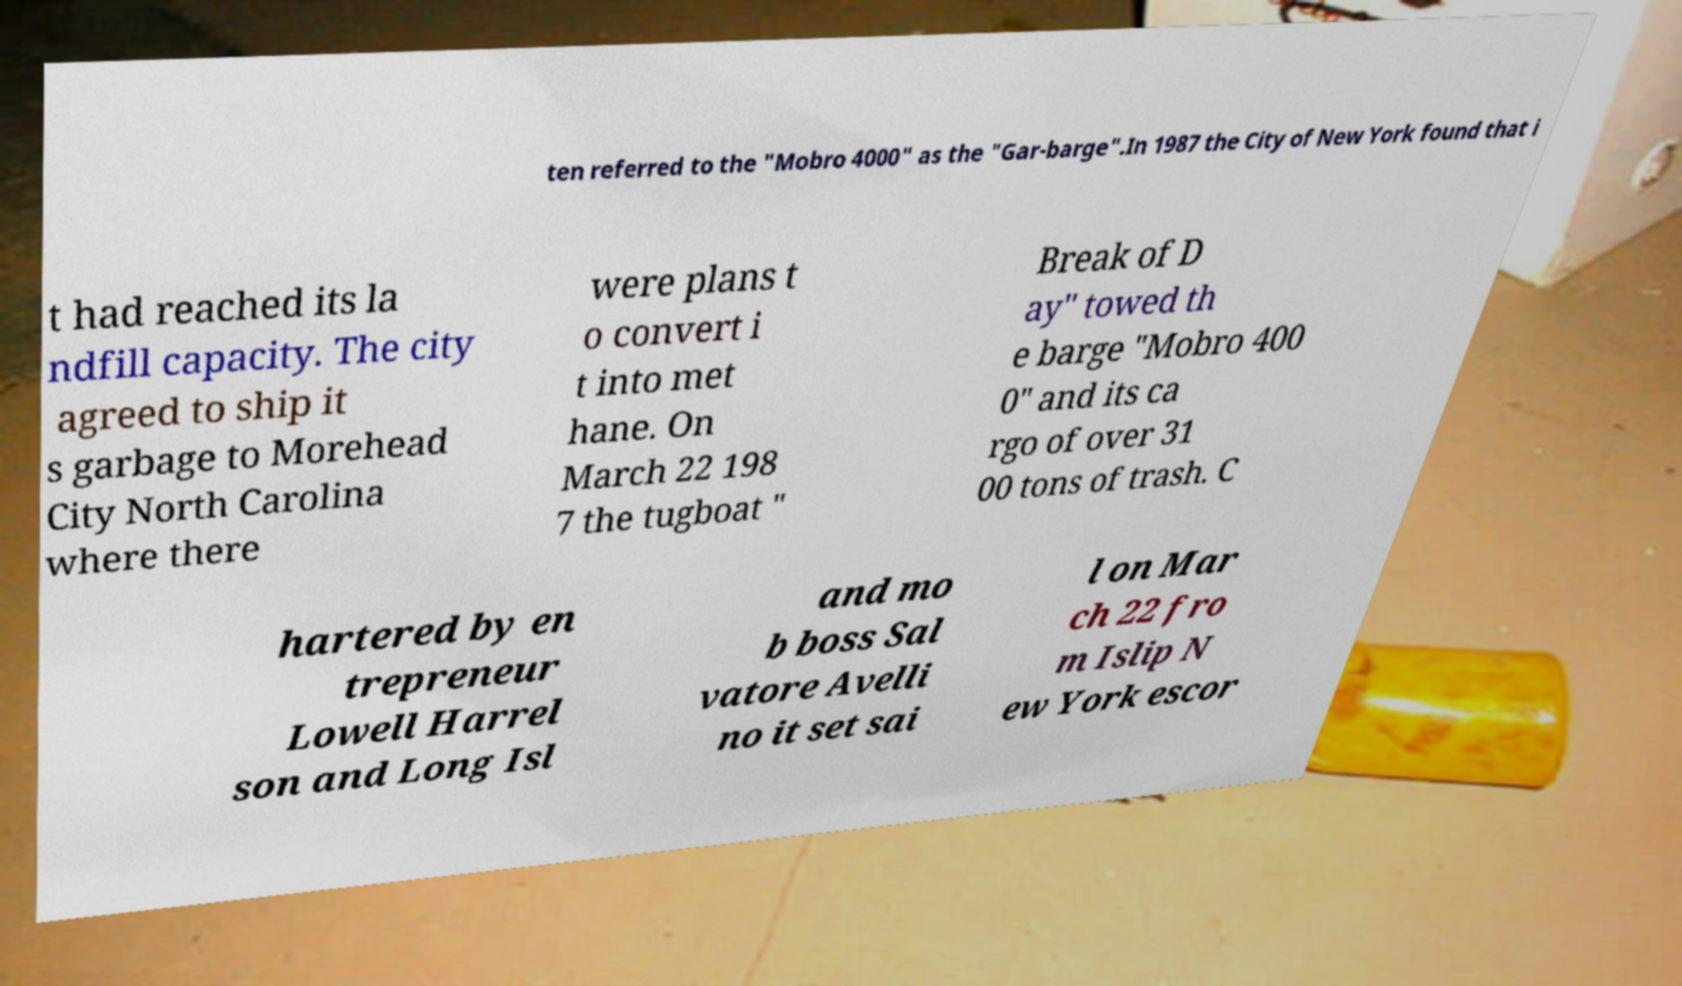Can you read and provide the text displayed in the image?This photo seems to have some interesting text. Can you extract and type it out for me? ten referred to the "Mobro 4000" as the "Gar-barge".In 1987 the City of New York found that i t had reached its la ndfill capacity. The city agreed to ship it s garbage to Morehead City North Carolina where there were plans t o convert i t into met hane. On March 22 198 7 the tugboat " Break of D ay" towed th e barge "Mobro 400 0" and its ca rgo of over 31 00 tons of trash. C hartered by en trepreneur Lowell Harrel son and Long Isl and mo b boss Sal vatore Avelli no it set sai l on Mar ch 22 fro m Islip N ew York escor 